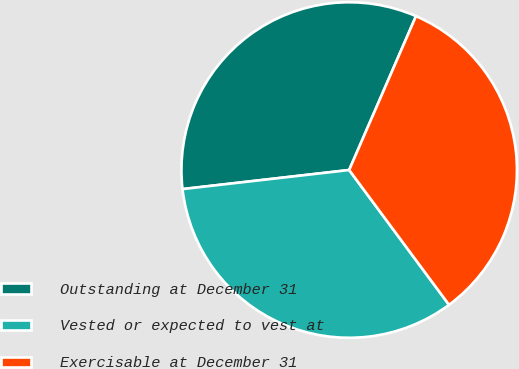<chart> <loc_0><loc_0><loc_500><loc_500><pie_chart><fcel>Outstanding at December 31<fcel>Vested or expected to vest at<fcel>Exercisable at December 31<nl><fcel>33.33%<fcel>33.33%<fcel>33.33%<nl></chart> 